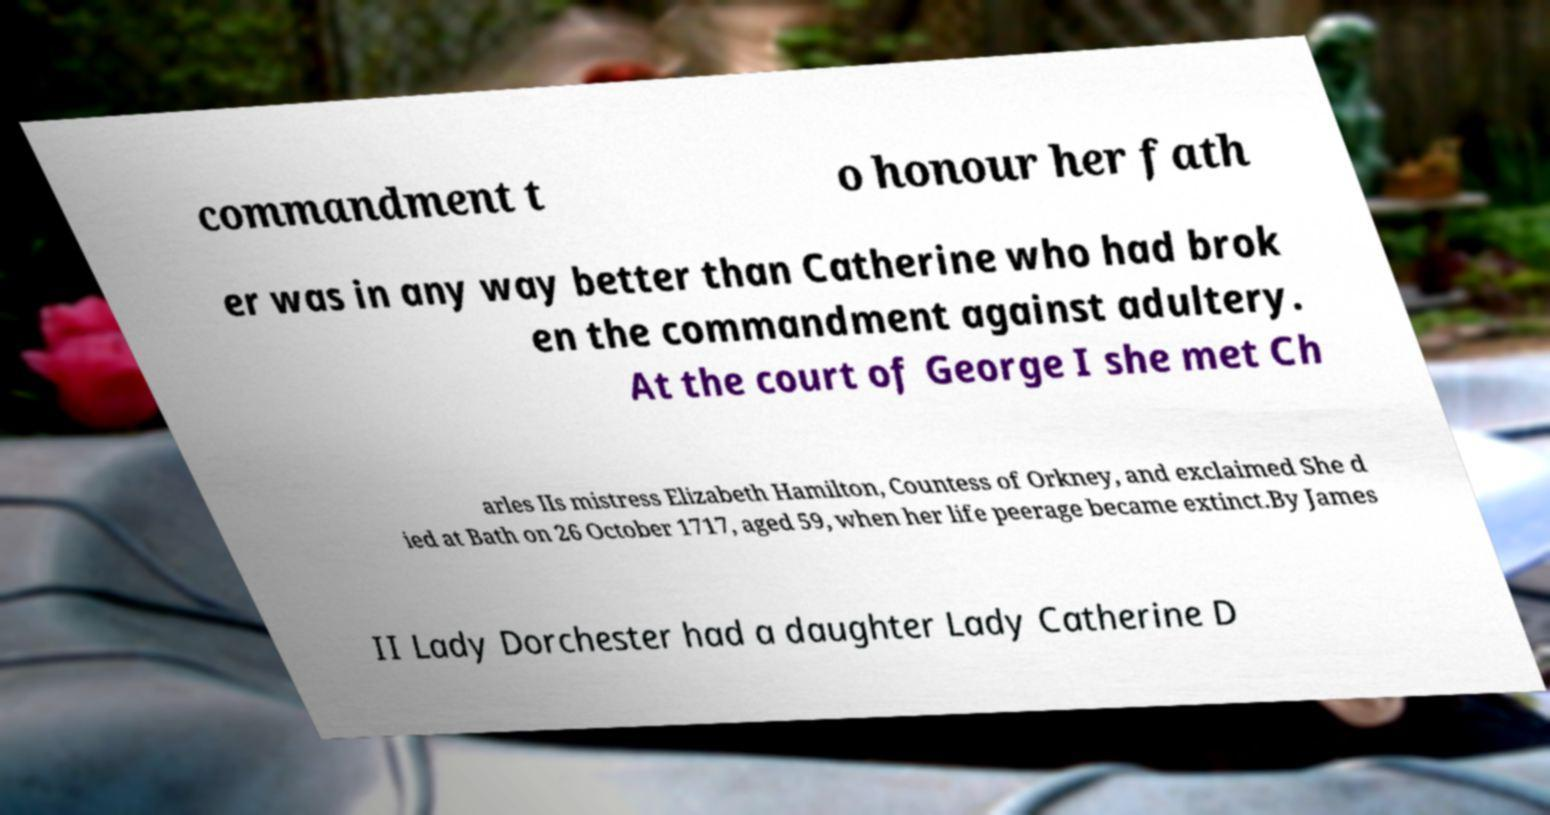Could you assist in decoding the text presented in this image and type it out clearly? commandment t o honour her fath er was in any way better than Catherine who had brok en the commandment against adultery. At the court of George I she met Ch arles IIs mistress Elizabeth Hamilton, Countess of Orkney, and exclaimed She d ied at Bath on 26 October 1717, aged 59, when her life peerage became extinct.By James II Lady Dorchester had a daughter Lady Catherine D 